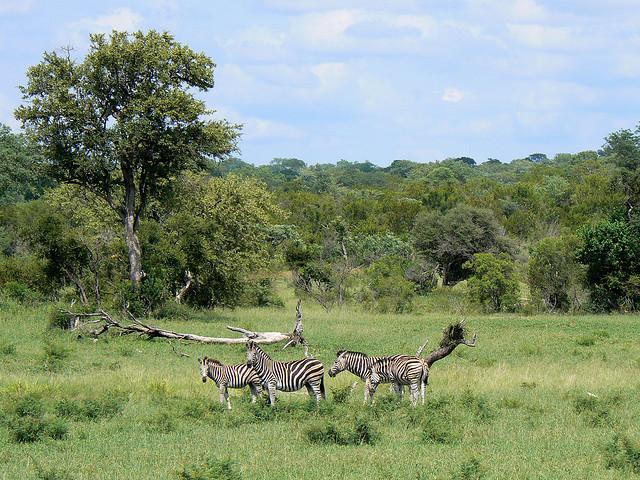Is this creature curious about the thing looking at it?
Concise answer only. Yes. How many zebras standing?
Write a very short answer. 3. What color are the animals in the photo?
Quick response, please. Black and white. Do the zebras appear lost?
Write a very short answer. No. Are there more animals?
Concise answer only. No. Are both of these animals striped?
Concise answer only. Yes. What season is it in this picture?
Be succinct. Summer. What are these animals?
Be succinct. Zebras. 